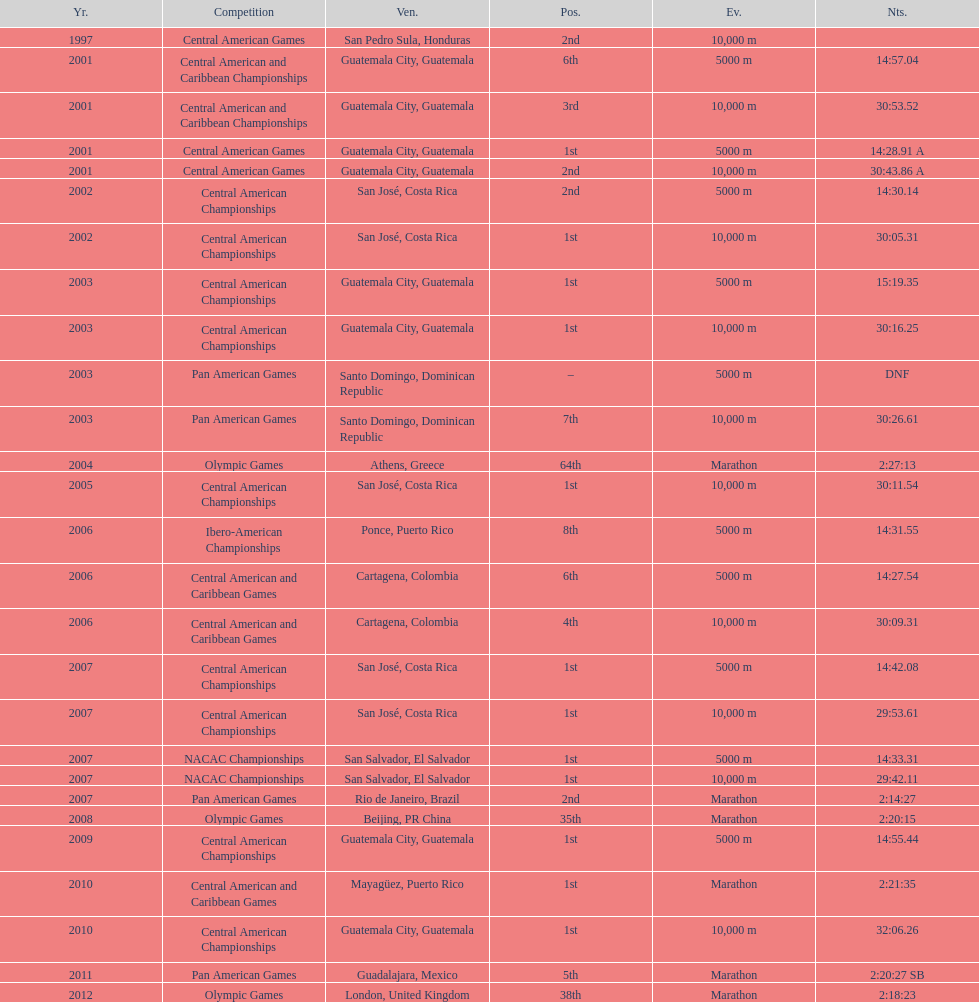What competition did this competitor compete at after participating in the central american games in 2001? Central American Championships. 